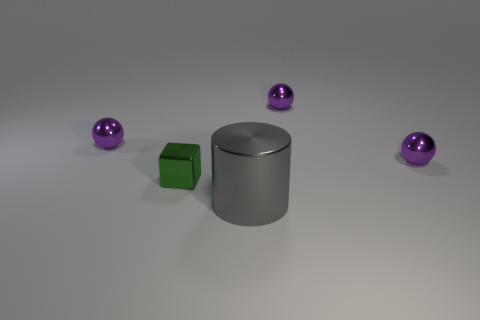Subtract all purple balls. How many were subtracted if there are1purple balls left? 2 Add 1 gray shiny things. How many objects exist? 6 Subtract all cubes. How many objects are left? 4 Add 4 large blue matte things. How many large blue matte things exist? 4 Subtract 1 gray cylinders. How many objects are left? 4 Subtract all small metallic balls. Subtract all blocks. How many objects are left? 1 Add 4 big gray shiny cylinders. How many big gray shiny cylinders are left? 5 